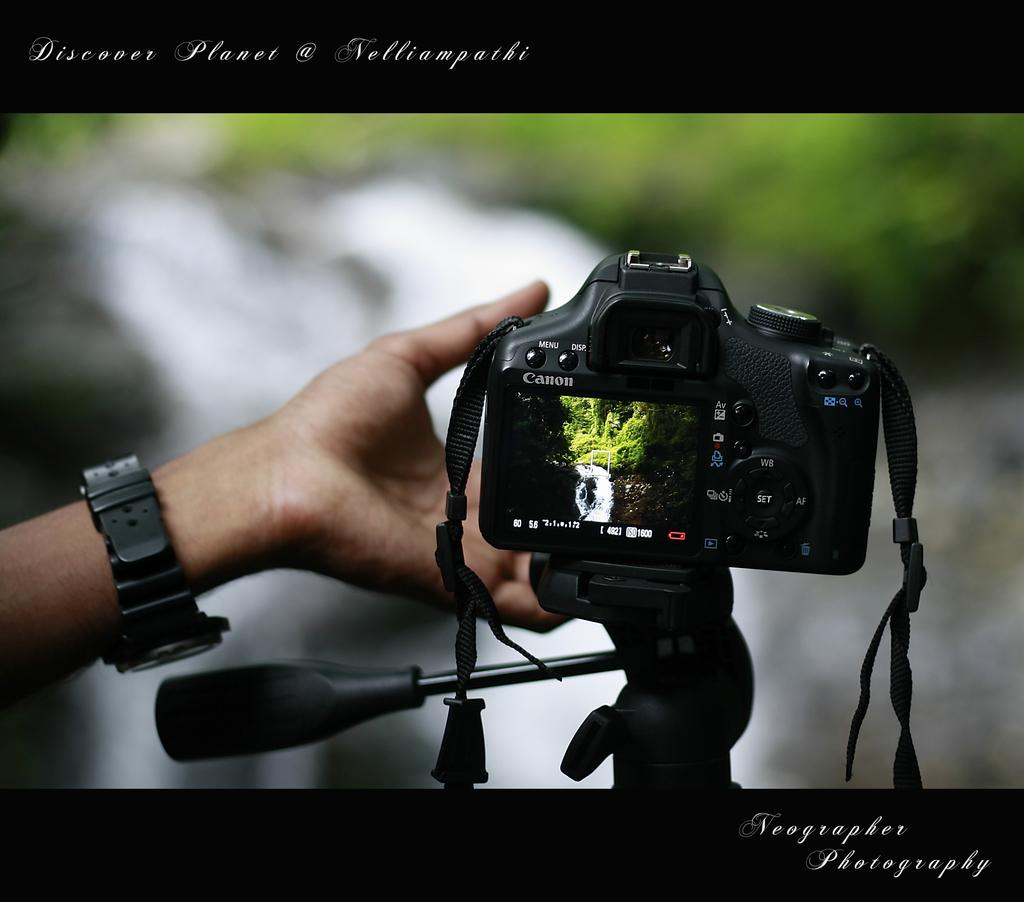<image>
Present a compact description of the photo's key features. A Canon digital camera capturing a picture of a waterfall. 